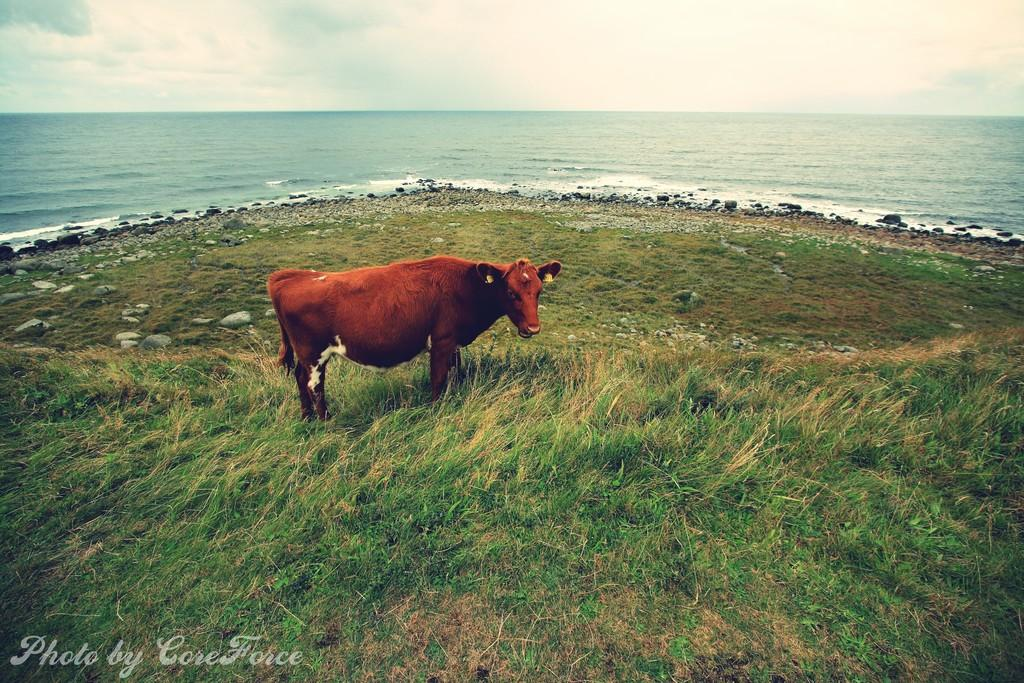What animal is standing on the grass in the image? There is a cow standing on the grass in the image. What can be seen in the background of the image? In the background, there are rocks, water, and the sky visible. Can you describe the water in the background? The water is visible in the background, but its specific location or size cannot be determined from the image. What is present in the right corner of the image? There is a watermark in the right corner of the image. How many bikes are being compared in the image? There are no bikes present in the image, and therefore no comparison can be made. 